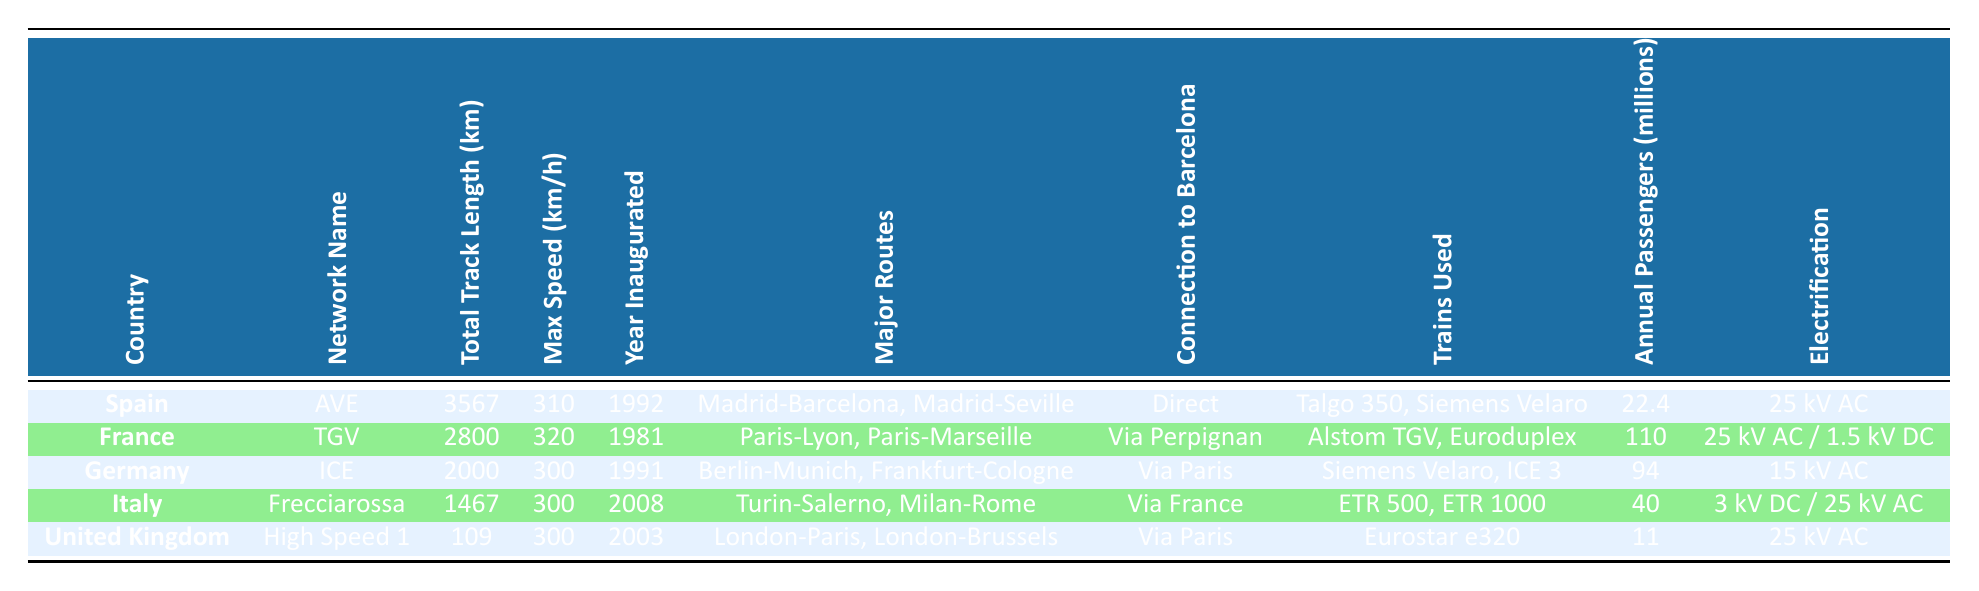What is the max speed of the TGV? The TGV is listed in the table under France, and its max speed is shown as 320 km/h.
Answer: 320 km/h How many annual passengers does the ICE network serve? Looking at the ICE network listed under Germany, it indicates that it serves 94 million annual passengers.
Answer: 94 million Which country has the highest total track length for its high-speed train network? By comparing the total track lengths in the table, Spain has the highest at 3567 km for its AVE network.
Answer: Spain Does the Frecciarossa provide a direct connection to Barcelona? The Frecciarossa network does not connect directly to Barcelona, as it states "Via France" in the connections column.
Answer: No What is the average maximum speed of the listed networks? To find the average maximum speed, we sum the max speeds: 310 (Spain) + 320 (France) + 300 (Germany) + 300 (Italy) + 300 (UK) = 1530 km/h. Next, we divide by the number of networks (5): 1530 / 5 = 306 km/h.
Answer: 306 km/h Which high-speed train network was inaugurated most recently? The table lists the years the networks were inaugurated. The Frecciarossa in Italy is the most recent, inaugurated in 2008.
Answer: Frecciarossa Is the electrification for Germany's ICE network higher than that of the UK’s High Speed 1? The ICE network uses 15 kV AC, while High Speed 1 uses 25 kV AC. Since 25 kV AC is higher than 15 kV AC, the answer is yes.
Answer: Yes What are the major routes for the AVE network? To find this information, we look at the AVE network under Spain in the table, which highlights the major routes as "Madrid-Barcelona, Madrid-Seville."
Answer: Madrid-Barcelona, Madrid-Seville 